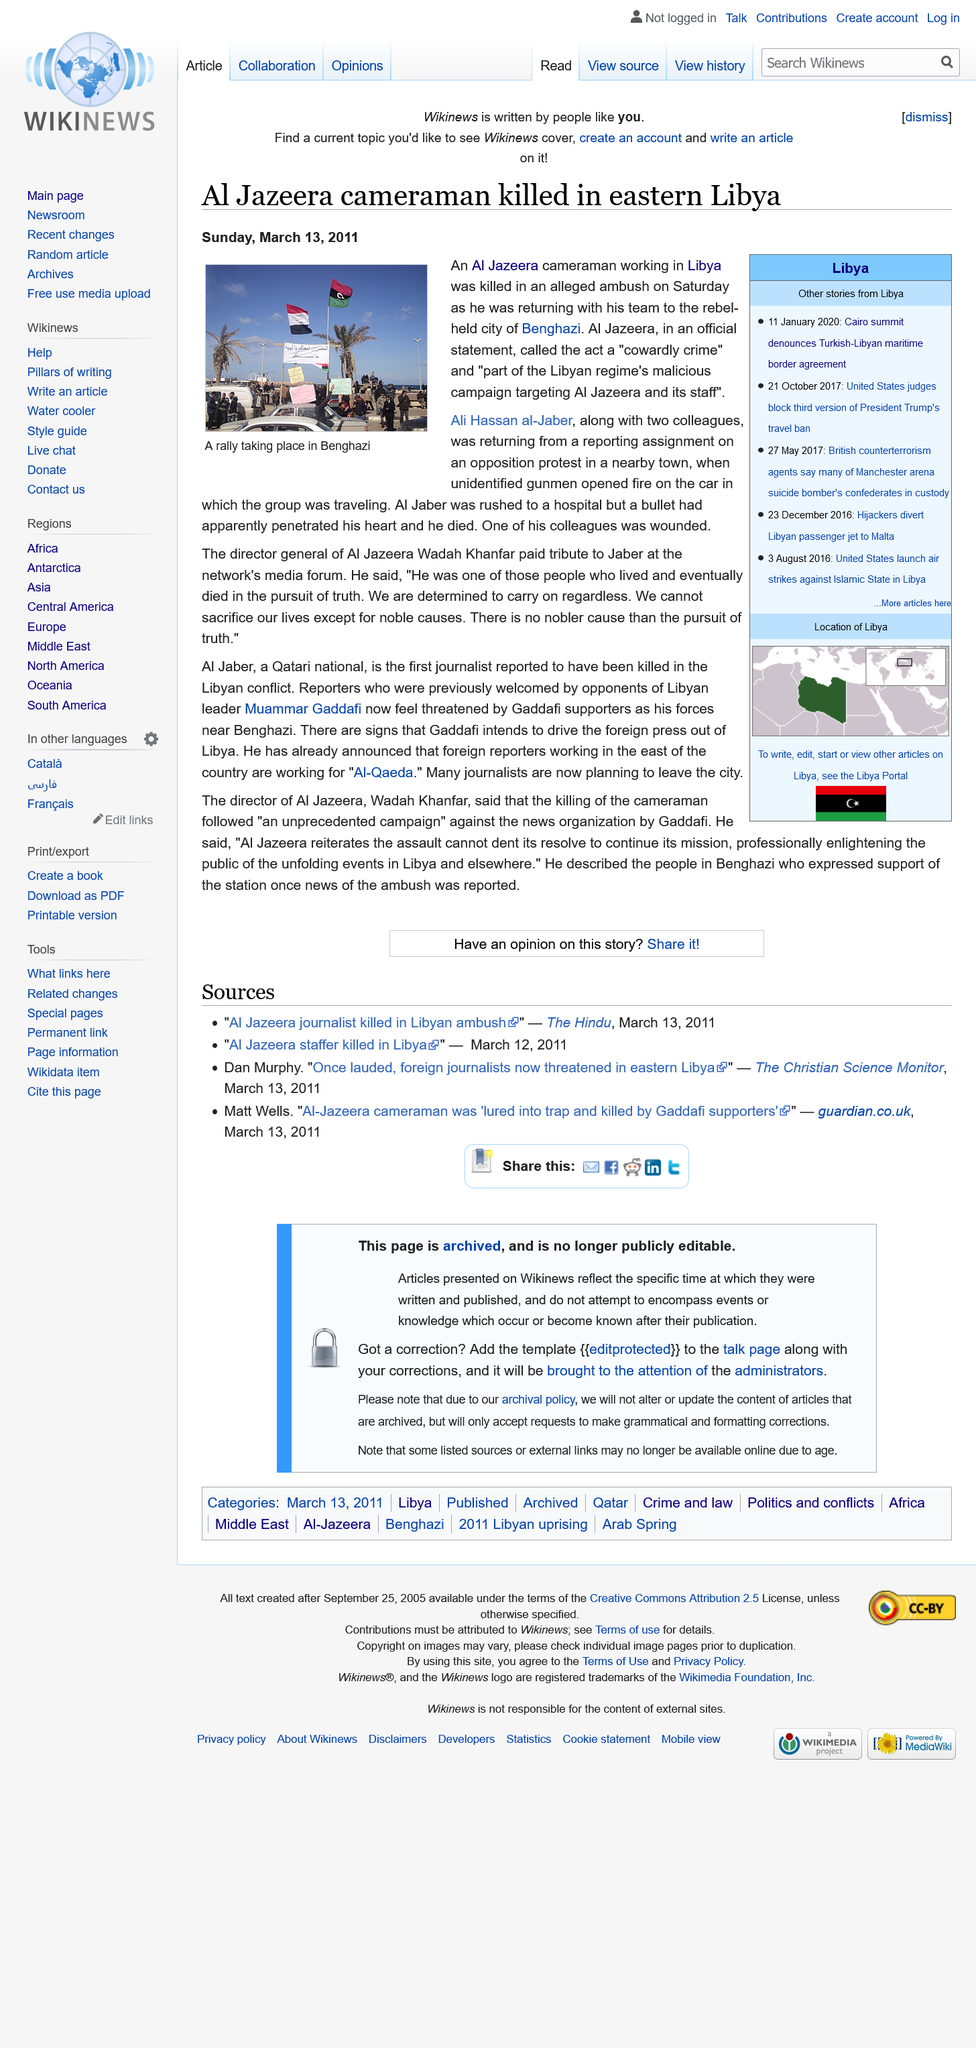Mention a couple of crucial points in this snapshot. It is confirmed that a significant number of journalists are preparing to leave the city. Ali Hassan al-Jaber was shot while working in Libya. Ali Hassan al-Jaber was shot by a bullet that penetrated his heart while he was travelling with two colleagues. 